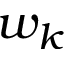Convert formula to latex. <formula><loc_0><loc_0><loc_500><loc_500>w _ { k }</formula> 